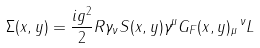<formula> <loc_0><loc_0><loc_500><loc_500>\Sigma ( x , y ) = \frac { i g ^ { 2 } } { 2 } R \gamma _ { \nu } S ( x , y ) \gamma ^ { \mu } G _ { F } ( x , y ) _ { \mu } \, ^ { \nu } L</formula> 